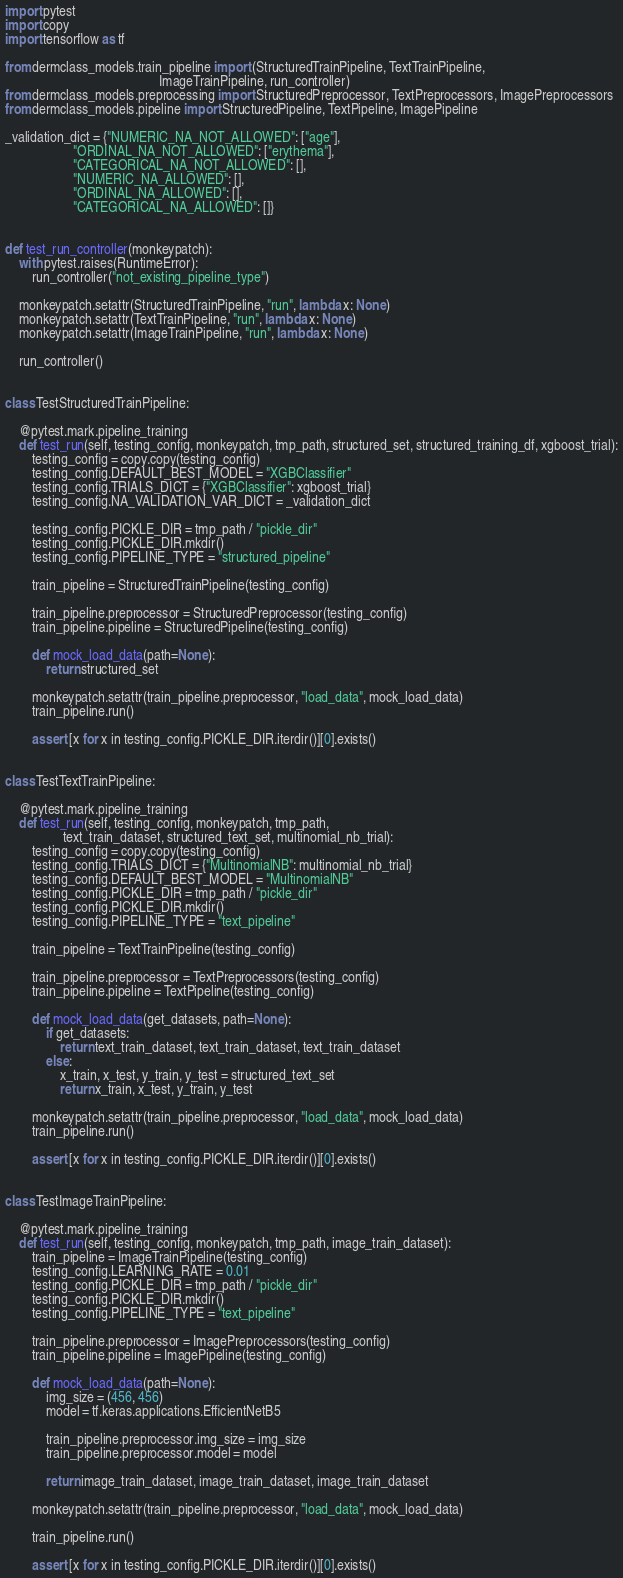Convert code to text. <code><loc_0><loc_0><loc_500><loc_500><_Python_>import pytest
import copy
import tensorflow as tf

from dermclass_models.train_pipeline import (StructuredTrainPipeline, TextTrainPipeline,
                                             ImageTrainPipeline, run_controller)
from dermclass_models.preprocessing import StructuredPreprocessor, TextPreprocessors, ImagePreprocessors
from dermclass_models.pipeline import StructuredPipeline, TextPipeline, ImagePipeline

_validation_dict = {"NUMERIC_NA_NOT_ALLOWED": ["age"],
                    "ORDINAL_NA_NOT_ALLOWED": ["erythema"],
                    "CATEGORICAL_NA_NOT_ALLOWED": [],
                    "NUMERIC_NA_ALLOWED": [],
                    "ORDINAL_NA_ALLOWED": [],
                    "CATEGORICAL_NA_ALLOWED": []}


def test_run_controller(monkeypatch):
    with pytest.raises(RuntimeError):
        run_controller("not_existing_pipeline_type")

    monkeypatch.setattr(StructuredTrainPipeline, "run", lambda x: None)
    monkeypatch.setattr(TextTrainPipeline, "run", lambda x: None)
    monkeypatch.setattr(ImageTrainPipeline, "run", lambda x: None)

    run_controller()


class TestStructuredTrainPipeline:

    @pytest.mark.pipeline_training
    def test_run(self, testing_config, monkeypatch, tmp_path, structured_set, structured_training_df, xgboost_trial):
        testing_config = copy.copy(testing_config)
        testing_config.DEFAULT_BEST_MODEL = "XGBClassifier"
        testing_config.TRIALS_DICT = {"XGBClassifier": xgboost_trial}
        testing_config.NA_VALIDATION_VAR_DICT = _validation_dict

        testing_config.PICKLE_DIR = tmp_path / "pickle_dir"
        testing_config.PICKLE_DIR.mkdir()
        testing_config.PIPELINE_TYPE = "structured_pipeline"

        train_pipeline = StructuredTrainPipeline(testing_config)

        train_pipeline.preprocessor = StructuredPreprocessor(testing_config)
        train_pipeline.pipeline = StructuredPipeline(testing_config)

        def mock_load_data(path=None):
            return structured_set

        monkeypatch.setattr(train_pipeline.preprocessor, "load_data", mock_load_data)
        train_pipeline.run()

        assert [x for x in testing_config.PICKLE_DIR.iterdir()][0].exists()


class TestTextTrainPipeline:

    @pytest.mark.pipeline_training
    def test_run(self, testing_config, monkeypatch, tmp_path,
                 text_train_dataset, structured_text_set, multinomial_nb_trial):
        testing_config = copy.copy(testing_config)
        testing_config.TRIALS_DICT = {"MultinomialNB": multinomial_nb_trial}
        testing_config.DEFAULT_BEST_MODEL = "MultinomialNB"
        testing_config.PICKLE_DIR = tmp_path / "pickle_dir"
        testing_config.PICKLE_DIR.mkdir()
        testing_config.PIPELINE_TYPE = "text_pipeline"

        train_pipeline = TextTrainPipeline(testing_config)

        train_pipeline.preprocessor = TextPreprocessors(testing_config)
        train_pipeline.pipeline = TextPipeline(testing_config)

        def mock_load_data(get_datasets, path=None):
            if get_datasets:
                return text_train_dataset, text_train_dataset, text_train_dataset
            else:
                x_train, x_test, y_train, y_test = structured_text_set
                return x_train, x_test, y_train, y_test

        monkeypatch.setattr(train_pipeline.preprocessor, "load_data", mock_load_data)
        train_pipeline.run()

        assert [x for x in testing_config.PICKLE_DIR.iterdir()][0].exists()


class TestImageTrainPipeline:

    @pytest.mark.pipeline_training
    def test_run(self, testing_config, monkeypatch, tmp_path, image_train_dataset):
        train_pipeline = ImageTrainPipeline(testing_config)
        testing_config.LEARNING_RATE = 0.01
        testing_config.PICKLE_DIR = tmp_path / "pickle_dir"
        testing_config.PICKLE_DIR.mkdir()
        testing_config.PIPELINE_TYPE = "text_pipeline"

        train_pipeline.preprocessor = ImagePreprocessors(testing_config)
        train_pipeline.pipeline = ImagePipeline(testing_config)

        def mock_load_data(path=None):
            img_size = (456, 456)
            model = tf.keras.applications.EfficientNetB5

            train_pipeline.preprocessor.img_size = img_size
            train_pipeline.preprocessor.model = model

            return image_train_dataset, image_train_dataset, image_train_dataset

        monkeypatch.setattr(train_pipeline.preprocessor, "load_data", mock_load_data)

        train_pipeline.run()

        assert [x for x in testing_config.PICKLE_DIR.iterdir()][0].exists()
</code> 